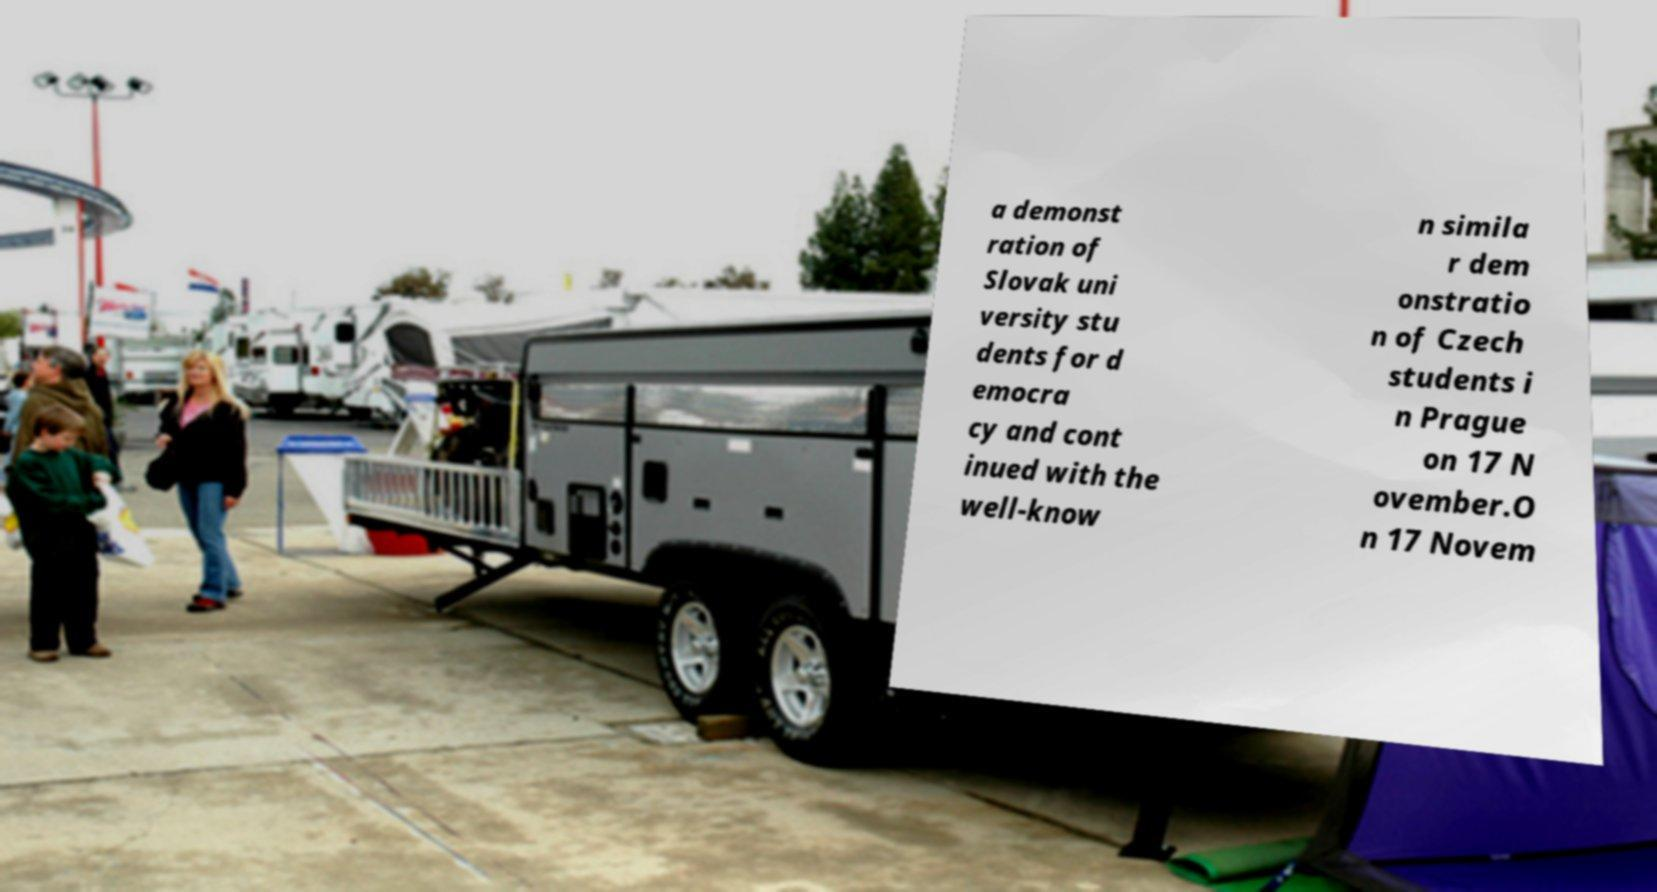For documentation purposes, I need the text within this image transcribed. Could you provide that? a demonst ration of Slovak uni versity stu dents for d emocra cy and cont inued with the well-know n simila r dem onstratio n of Czech students i n Prague on 17 N ovember.O n 17 Novem 